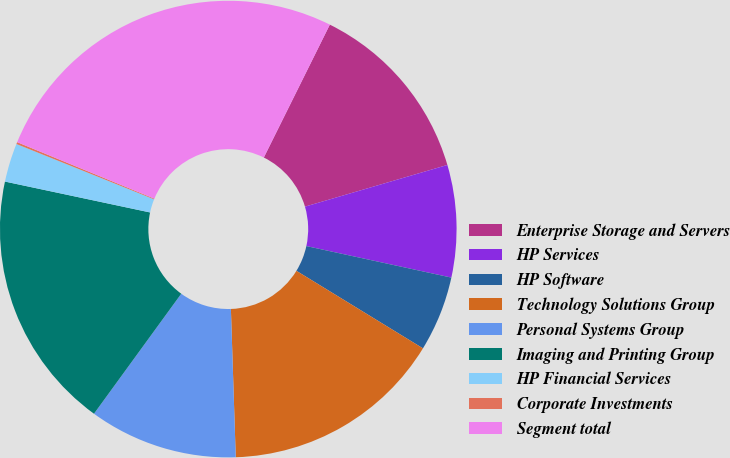Convert chart to OTSL. <chart><loc_0><loc_0><loc_500><loc_500><pie_chart><fcel>Enterprise Storage and Servers<fcel>HP Services<fcel>HP Software<fcel>Technology Solutions Group<fcel>Personal Systems Group<fcel>Imaging and Printing Group<fcel>HP Financial Services<fcel>Corporate Investments<fcel>Segment total<nl><fcel>13.13%<fcel>7.94%<fcel>5.34%<fcel>15.73%<fcel>10.53%<fcel>18.33%<fcel>2.74%<fcel>0.14%<fcel>26.12%<nl></chart> 